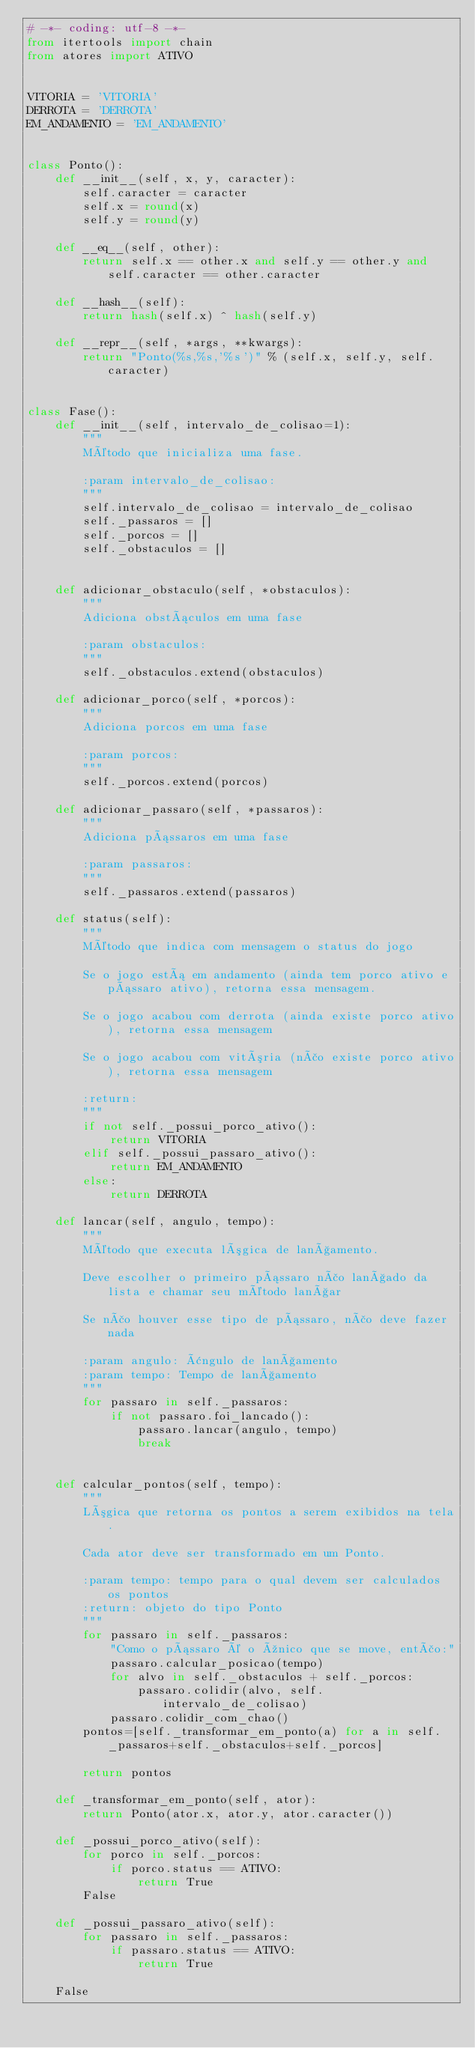Convert code to text. <code><loc_0><loc_0><loc_500><loc_500><_Python_># -*- coding: utf-8 -*-
from itertools import chain
from atores import ATIVO


VITORIA = 'VITORIA'
DERROTA = 'DERROTA'
EM_ANDAMENTO = 'EM_ANDAMENTO'


class Ponto():
    def __init__(self, x, y, caracter):
        self.caracter = caracter
        self.x = round(x)
        self.y = round(y)

    def __eq__(self, other):
        return self.x == other.x and self.y == other.y and self.caracter == other.caracter

    def __hash__(self):
        return hash(self.x) ^ hash(self.y)

    def __repr__(self, *args, **kwargs):
        return "Ponto(%s,%s,'%s')" % (self.x, self.y, self.caracter)


class Fase():
    def __init__(self, intervalo_de_colisao=1):
        """
        Método que inicializa uma fase.

        :param intervalo_de_colisao:
        """
        self.intervalo_de_colisao = intervalo_de_colisao
        self._passaros = []
        self._porcos = []
        self._obstaculos = []


    def adicionar_obstaculo(self, *obstaculos):
        """
        Adiciona obstáculos em uma fase

        :param obstaculos:
        """
        self._obstaculos.extend(obstaculos)

    def adicionar_porco(self, *porcos):
        """
        Adiciona porcos em uma fase

        :param porcos:
        """
        self._porcos.extend(porcos)

    def adicionar_passaro(self, *passaros):
        """
        Adiciona pássaros em uma fase

        :param passaros:
        """
        self._passaros.extend(passaros)

    def status(self):
        """
        Método que indica com mensagem o status do jogo

        Se o jogo está em andamento (ainda tem porco ativo e pássaro ativo), retorna essa mensagem.

        Se o jogo acabou com derrota (ainda existe porco ativo), retorna essa mensagem

        Se o jogo acabou com vitória (não existe porco ativo), retorna essa mensagem

        :return:
        """
        if not self._possui_porco_ativo():
            return VITORIA
        elif self._possui_passaro_ativo():
            return EM_ANDAMENTO
        else:
            return DERROTA

    def lancar(self, angulo, tempo):
        """
        Método que executa lógica de lançamento.

        Deve escolher o primeiro pássaro não lançado da lista e chamar seu método lançar

        Se não houver esse tipo de pássaro, não deve fazer nada

        :param angulo: ângulo de lançamento
        :param tempo: Tempo de lançamento
        """
        for passaro in self._passaros:
            if not passaro.foi_lancado():
                passaro.lancar(angulo, tempo)
                break


    def calcular_pontos(self, tempo):
        """
        Lógica que retorna os pontos a serem exibidos na tela.

        Cada ator deve ser transformado em um Ponto.

        :param tempo: tempo para o qual devem ser calculados os pontos
        :return: objeto do tipo Ponto
        """
        for passaro in self._passaros:
            "Como o pássaro é o único que se move, então:"
            passaro.calcular_posicao(tempo)
            for alvo in self._obstaculos + self._porcos:
                passaro.colidir(alvo, self.intervalo_de_colisao)
            passaro.colidir_com_chao()
        pontos=[self._transformar_em_ponto(a) for a in self._passaros+self._obstaculos+self._porcos]

        return pontos

    def _transformar_em_ponto(self, ator):
        return Ponto(ator.x, ator.y, ator.caracter())

    def _possui_porco_ativo(self):
        for porco in self._porcos:
            if porco.status == ATIVO:
                return True
        False

    def _possui_passaro_ativo(self):
        for passaro in self._passaros:
            if passaro.status == ATIVO:
                return True

    False

</code> 